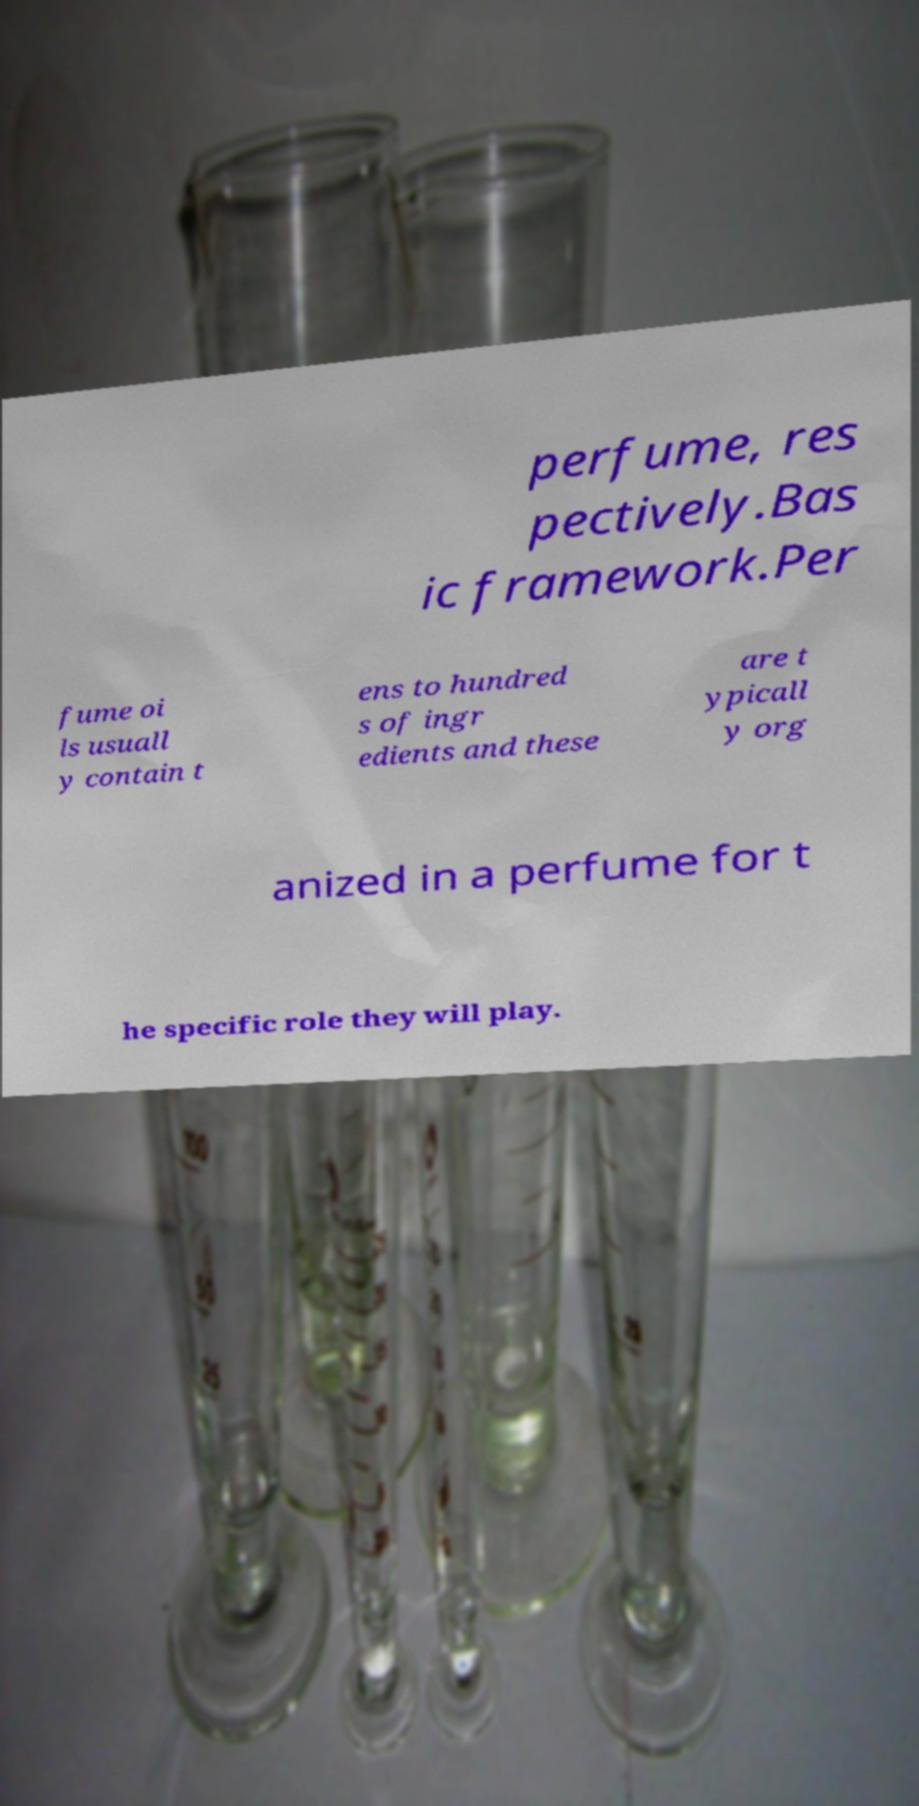Please read and relay the text visible in this image. What does it say? perfume, res pectively.Bas ic framework.Per fume oi ls usuall y contain t ens to hundred s of ingr edients and these are t ypicall y org anized in a perfume for t he specific role they will play. 